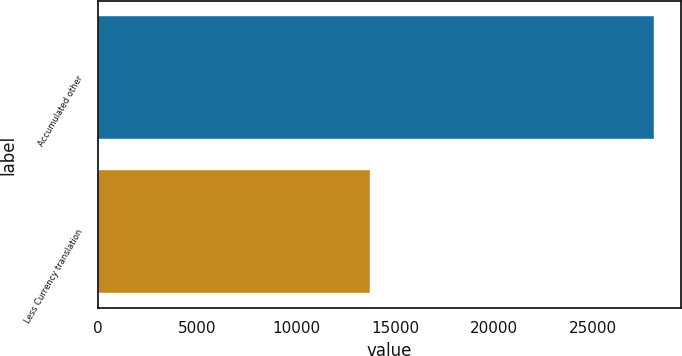<chart> <loc_0><loc_0><loc_500><loc_500><bar_chart><fcel>Accumulated other<fcel>Less Currency translation<nl><fcel>28033<fcel>13730<nl></chart> 